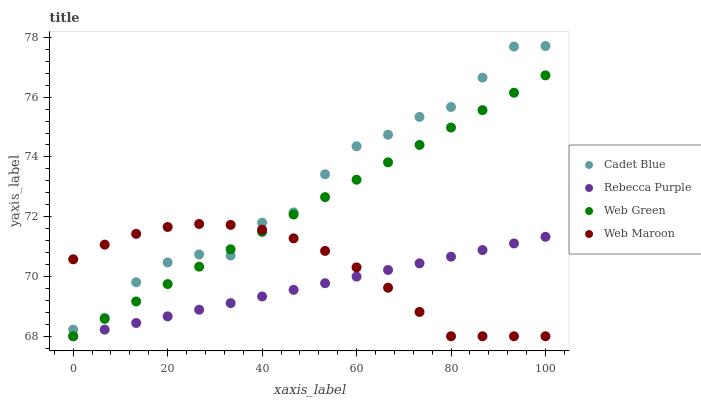Does Rebecca Purple have the minimum area under the curve?
Answer yes or no. Yes. Does Cadet Blue have the maximum area under the curve?
Answer yes or no. Yes. Does Web Maroon have the minimum area under the curve?
Answer yes or no. No. Does Web Maroon have the maximum area under the curve?
Answer yes or no. No. Is Rebecca Purple the smoothest?
Answer yes or no. Yes. Is Cadet Blue the roughest?
Answer yes or no. Yes. Is Web Maroon the smoothest?
Answer yes or no. No. Is Web Maroon the roughest?
Answer yes or no. No. Does Web Maroon have the lowest value?
Answer yes or no. Yes. Does Cadet Blue have the highest value?
Answer yes or no. Yes. Does Web Maroon have the highest value?
Answer yes or no. No. Is Rebecca Purple less than Cadet Blue?
Answer yes or no. Yes. Is Cadet Blue greater than Rebecca Purple?
Answer yes or no. Yes. Does Web Green intersect Rebecca Purple?
Answer yes or no. Yes. Is Web Green less than Rebecca Purple?
Answer yes or no. No. Is Web Green greater than Rebecca Purple?
Answer yes or no. No. Does Rebecca Purple intersect Cadet Blue?
Answer yes or no. No. 